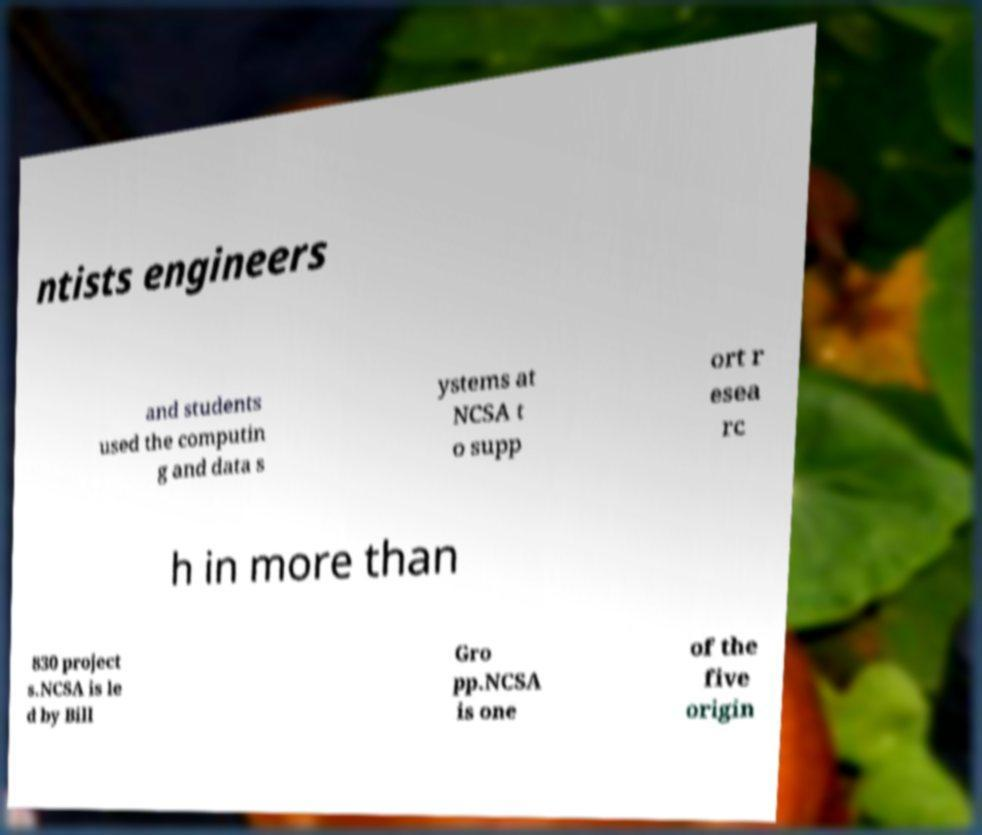I need the written content from this picture converted into text. Can you do that? ntists engineers and students used the computin g and data s ystems at NCSA t o supp ort r esea rc h in more than 830 project s.NCSA is le d by Bill Gro pp.NCSA is one of the five origin 